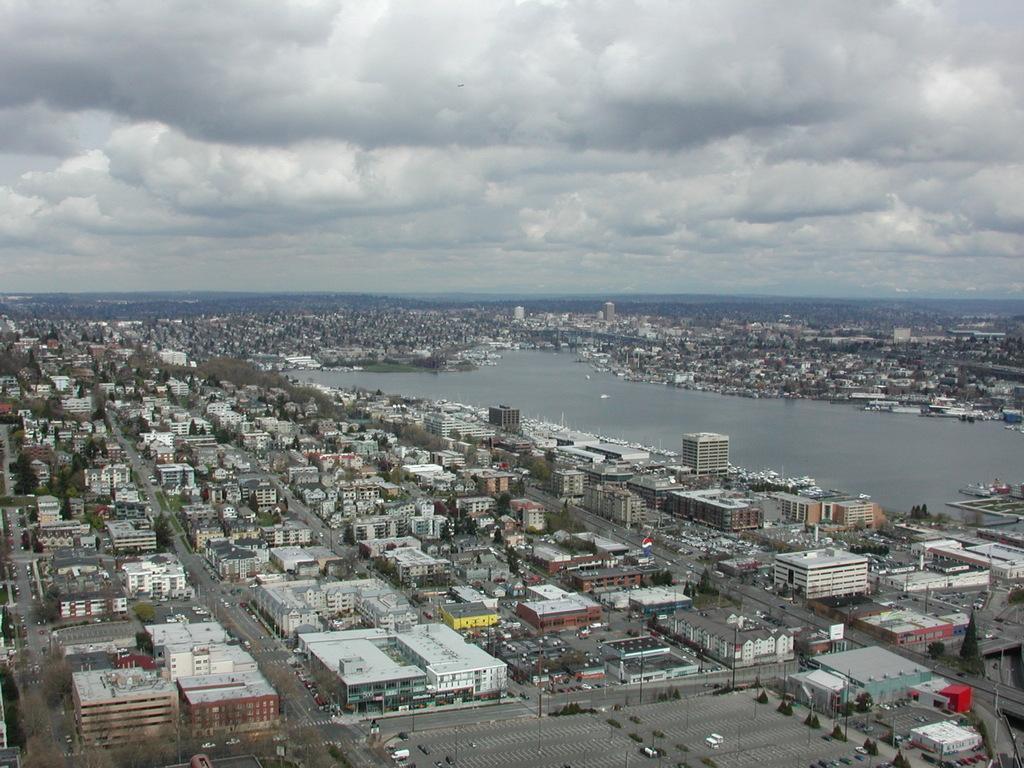How would you summarize this image in a sentence or two? This is the top view of the image where we can see buildings, roads, trees, water and sky with clouds. 